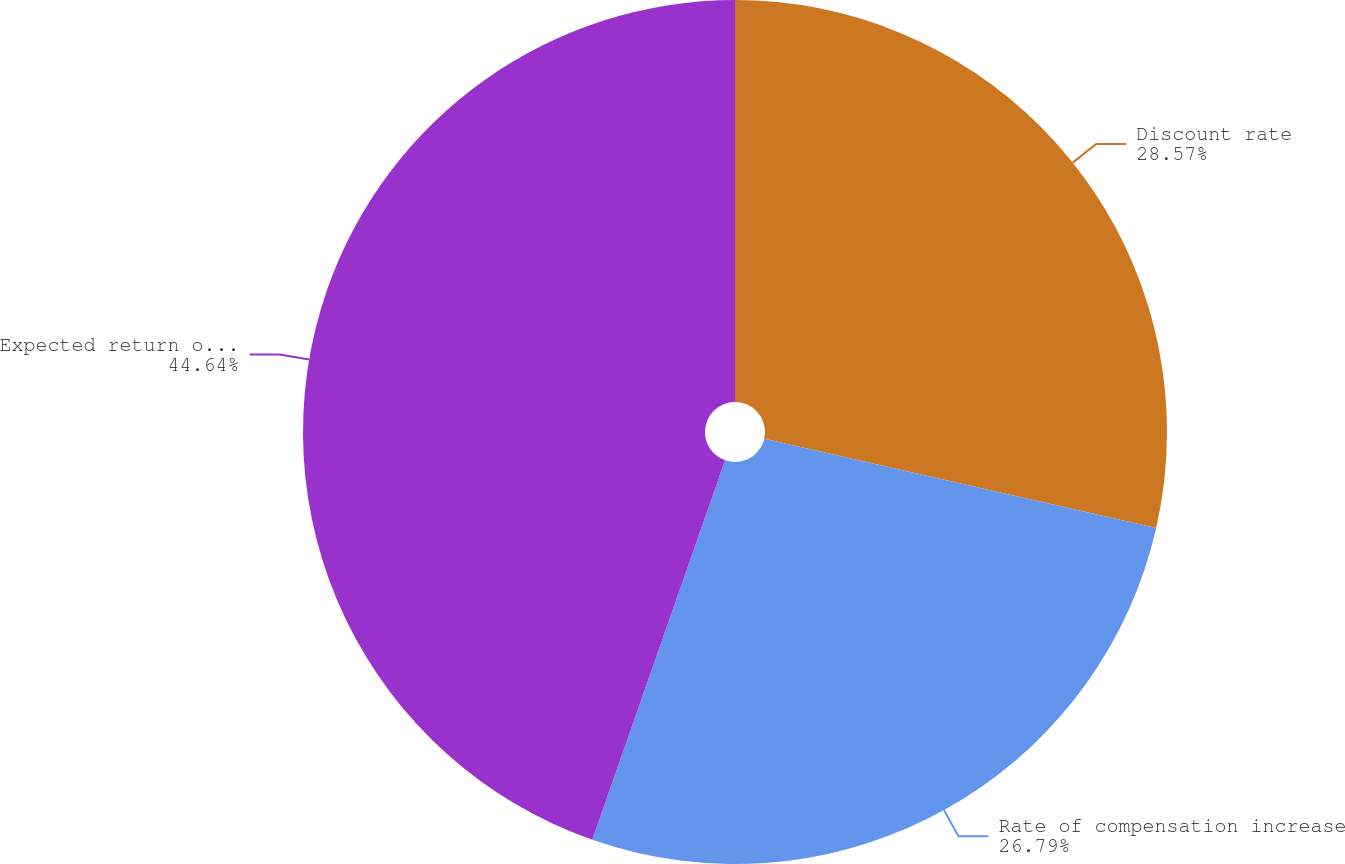Convert chart to OTSL. <chart><loc_0><loc_0><loc_500><loc_500><pie_chart><fcel>Discount rate<fcel>Rate of compensation increase<fcel>Expected return on plan assets<nl><fcel>28.57%<fcel>26.79%<fcel>44.64%<nl></chart> 